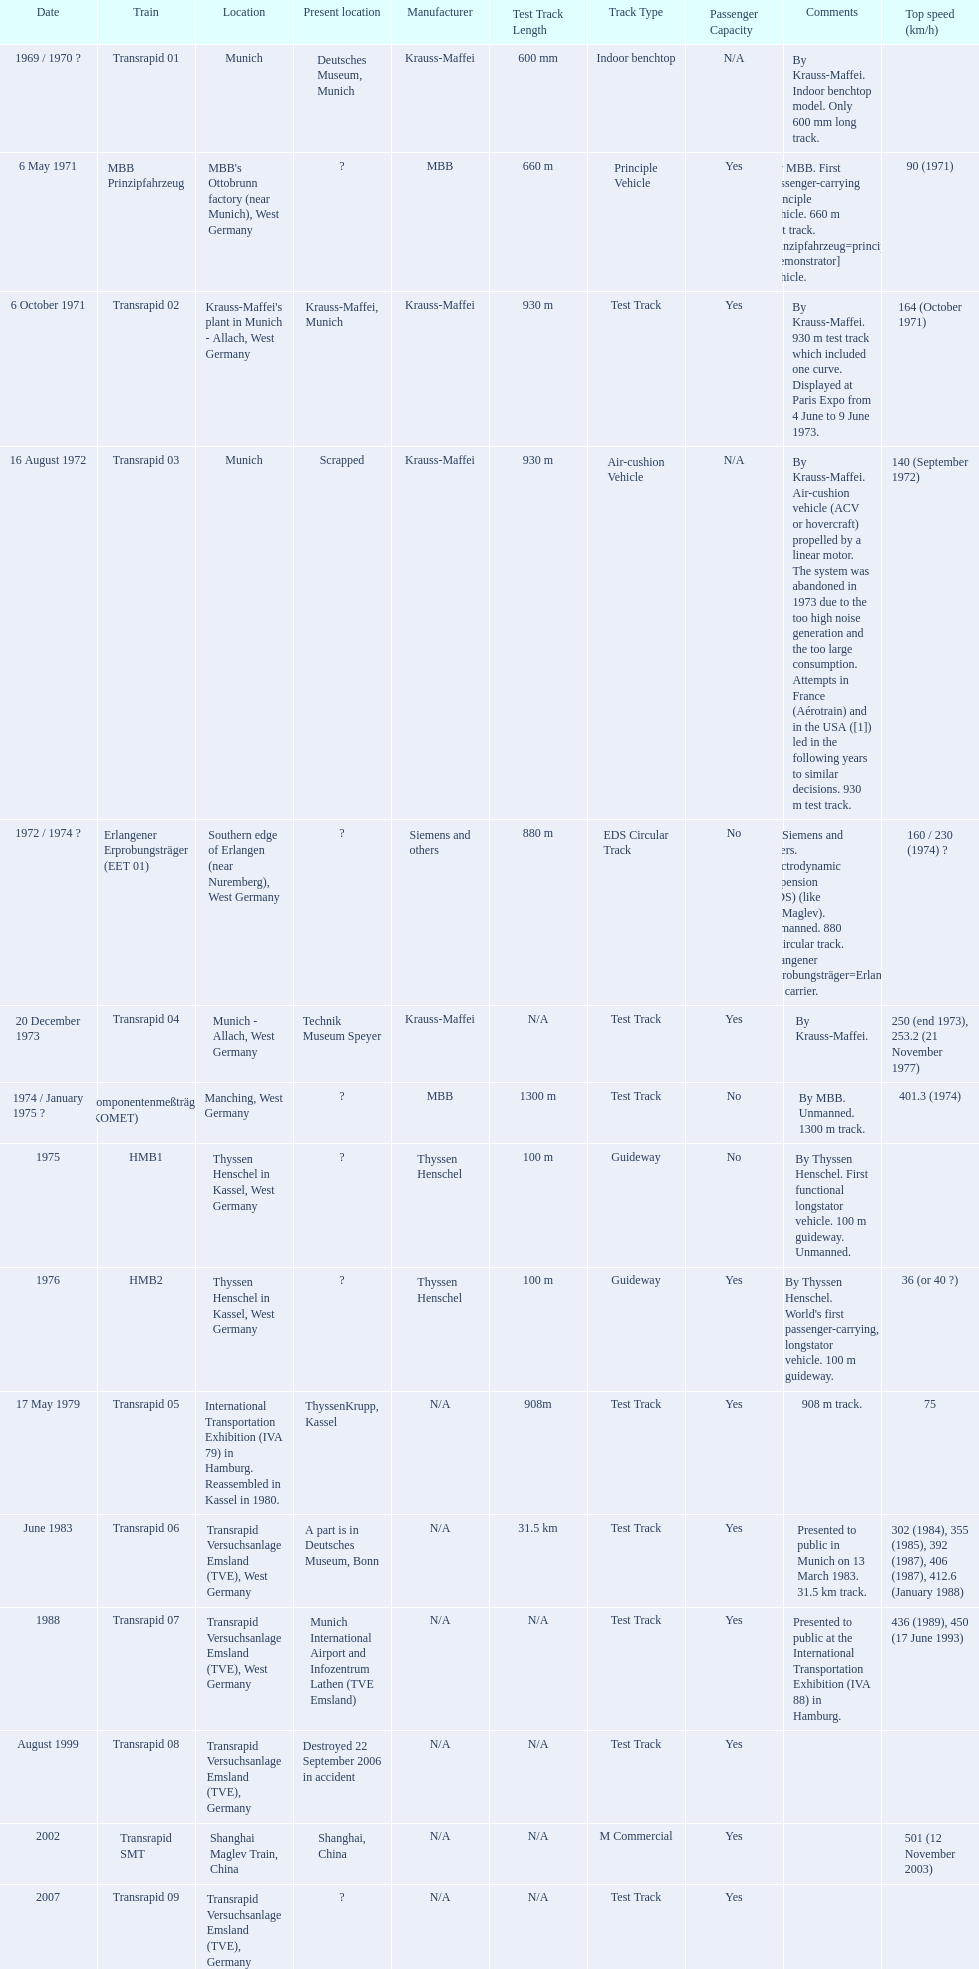What are all of the transrapid trains? Transrapid 01, Transrapid 02, Transrapid 03, Transrapid 04, Transrapid 05, Transrapid 06, Transrapid 07, Transrapid 08, Transrapid SMT, Transrapid 09. Of those, which train had to be scrapped? Transrapid 03. 